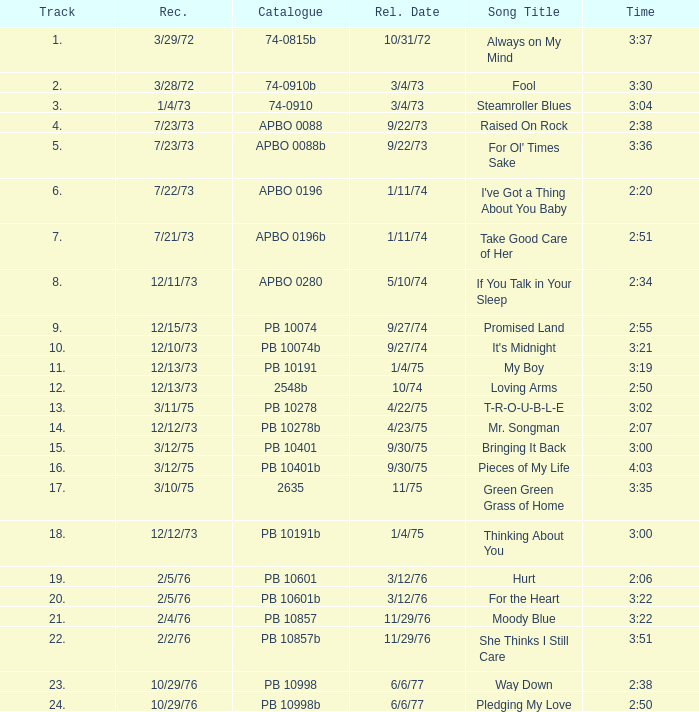Tell me the track that has the catalogue of apbo 0280 8.0. 